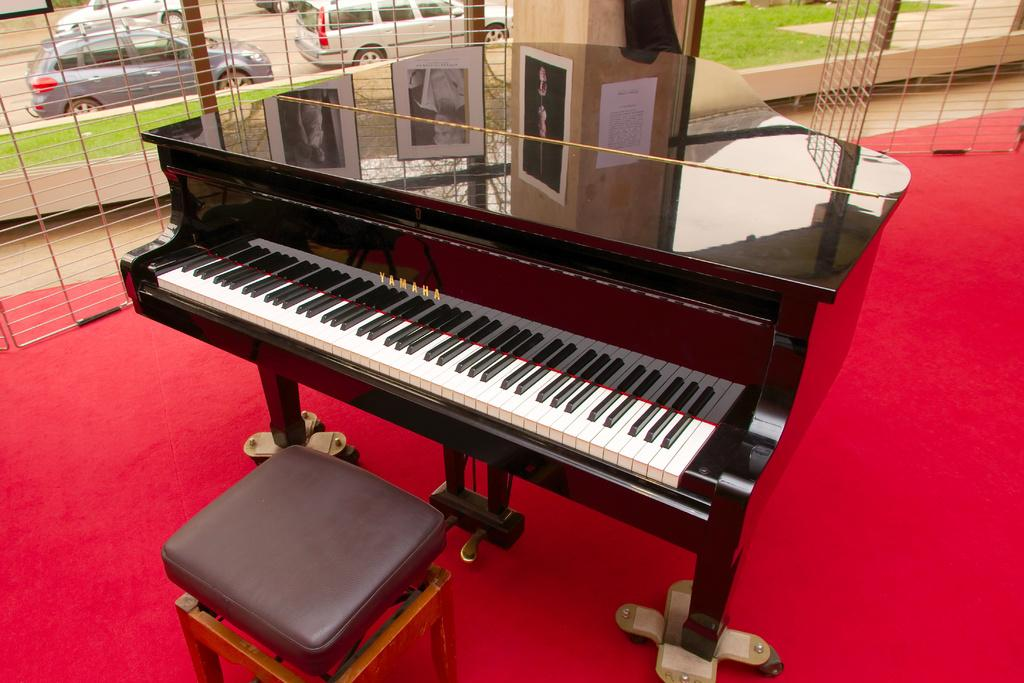What is the main object in the center of the image? There is a keyboard instrument in the center of the image. What is located below the keyboard instrument? There is a stool in the bottom of the image. What can be seen in the background of the image? There is a pillar, vehicles, grass, and a carpet visible in the background of the image. What type of pencil is being used to draw on the cake in the image? There is no pencil or cake present in the image; it features a keyboard instrument and a stool, with various elements visible in the background. 